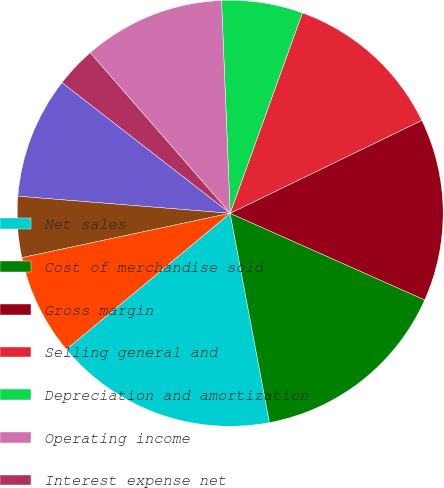Convert chart. <chart><loc_0><loc_0><loc_500><loc_500><pie_chart><fcel>Net sales<fcel>Cost of merchandise sold<fcel>Gross margin<fcel>Selling general and<fcel>Depreciation and amortization<fcel>Operating income<fcel>Interest expense net<fcel>Income before income taxes<fcel>Income tax expense<fcel>Net income<nl><fcel>16.92%<fcel>15.38%<fcel>13.85%<fcel>12.31%<fcel>6.15%<fcel>10.77%<fcel>3.08%<fcel>9.23%<fcel>4.62%<fcel>7.69%<nl></chart> 